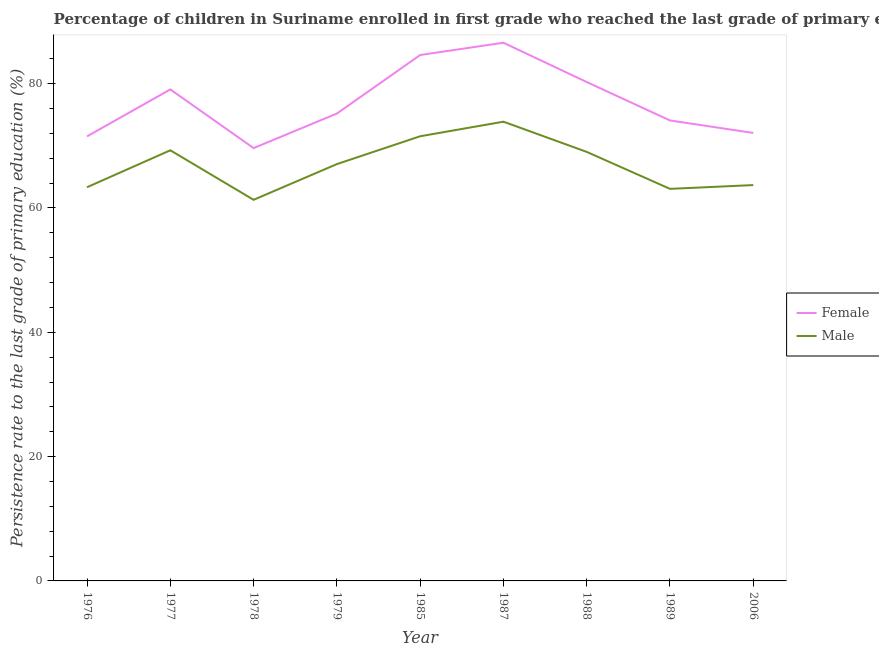Does the line corresponding to persistence rate of male students intersect with the line corresponding to persistence rate of female students?
Offer a very short reply. No. What is the persistence rate of female students in 1977?
Make the answer very short. 79.07. Across all years, what is the maximum persistence rate of female students?
Your answer should be compact. 86.58. Across all years, what is the minimum persistence rate of female students?
Offer a very short reply. 69.63. In which year was the persistence rate of female students minimum?
Your answer should be compact. 1978. What is the total persistence rate of male students in the graph?
Offer a very short reply. 602.19. What is the difference between the persistence rate of female students in 1979 and that in 1987?
Your answer should be very brief. -11.39. What is the difference between the persistence rate of male students in 1987 and the persistence rate of female students in 1976?
Give a very brief answer. 2.36. What is the average persistence rate of male students per year?
Provide a succinct answer. 66.91. In the year 1987, what is the difference between the persistence rate of male students and persistence rate of female students?
Your answer should be very brief. -12.7. In how many years, is the persistence rate of male students greater than 76 %?
Keep it short and to the point. 0. What is the ratio of the persistence rate of female students in 1977 to that in 1989?
Your answer should be very brief. 1.07. Is the persistence rate of male students in 1976 less than that in 1988?
Offer a very short reply. Yes. What is the difference between the highest and the second highest persistence rate of female students?
Offer a very short reply. 1.98. What is the difference between the highest and the lowest persistence rate of female students?
Give a very brief answer. 16.95. In how many years, is the persistence rate of female students greater than the average persistence rate of female students taken over all years?
Keep it short and to the point. 4. Is the sum of the persistence rate of female students in 1978 and 1988 greater than the maximum persistence rate of male students across all years?
Your response must be concise. Yes. Does the persistence rate of female students monotonically increase over the years?
Make the answer very short. No. How many lines are there?
Offer a very short reply. 2. How many years are there in the graph?
Provide a short and direct response. 9. Does the graph contain any zero values?
Ensure brevity in your answer.  No. Does the graph contain grids?
Your answer should be compact. No. How many legend labels are there?
Provide a short and direct response. 2. How are the legend labels stacked?
Give a very brief answer. Vertical. What is the title of the graph?
Provide a succinct answer. Percentage of children in Suriname enrolled in first grade who reached the last grade of primary education. Does "Rural Population" appear as one of the legend labels in the graph?
Provide a short and direct response. No. What is the label or title of the Y-axis?
Give a very brief answer. Persistence rate to the last grade of primary education (%). What is the Persistence rate to the last grade of primary education (%) of Female in 1976?
Your answer should be very brief. 71.52. What is the Persistence rate to the last grade of primary education (%) in Male in 1976?
Provide a succinct answer. 63.34. What is the Persistence rate to the last grade of primary education (%) in Female in 1977?
Offer a very short reply. 79.07. What is the Persistence rate to the last grade of primary education (%) of Male in 1977?
Give a very brief answer. 69.28. What is the Persistence rate to the last grade of primary education (%) of Female in 1978?
Ensure brevity in your answer.  69.63. What is the Persistence rate to the last grade of primary education (%) in Male in 1978?
Your answer should be very brief. 61.31. What is the Persistence rate to the last grade of primary education (%) in Female in 1979?
Offer a terse response. 75.19. What is the Persistence rate to the last grade of primary education (%) in Male in 1979?
Offer a terse response. 67.06. What is the Persistence rate to the last grade of primary education (%) in Female in 1985?
Provide a succinct answer. 84.61. What is the Persistence rate to the last grade of primary education (%) of Male in 1985?
Your response must be concise. 71.54. What is the Persistence rate to the last grade of primary education (%) of Female in 1987?
Provide a succinct answer. 86.58. What is the Persistence rate to the last grade of primary education (%) in Male in 1987?
Your answer should be very brief. 73.88. What is the Persistence rate to the last grade of primary education (%) of Female in 1988?
Make the answer very short. 80.26. What is the Persistence rate to the last grade of primary education (%) in Male in 1988?
Provide a succinct answer. 69.02. What is the Persistence rate to the last grade of primary education (%) of Female in 1989?
Offer a very short reply. 74.08. What is the Persistence rate to the last grade of primary education (%) in Male in 1989?
Give a very brief answer. 63.08. What is the Persistence rate to the last grade of primary education (%) in Female in 2006?
Offer a terse response. 72.07. What is the Persistence rate to the last grade of primary education (%) of Male in 2006?
Offer a terse response. 63.68. Across all years, what is the maximum Persistence rate to the last grade of primary education (%) in Female?
Provide a succinct answer. 86.58. Across all years, what is the maximum Persistence rate to the last grade of primary education (%) in Male?
Offer a terse response. 73.88. Across all years, what is the minimum Persistence rate to the last grade of primary education (%) of Female?
Ensure brevity in your answer.  69.63. Across all years, what is the minimum Persistence rate to the last grade of primary education (%) in Male?
Your answer should be compact. 61.31. What is the total Persistence rate to the last grade of primary education (%) in Female in the graph?
Your answer should be compact. 693.01. What is the total Persistence rate to the last grade of primary education (%) in Male in the graph?
Your answer should be compact. 602.19. What is the difference between the Persistence rate to the last grade of primary education (%) in Female in 1976 and that in 1977?
Offer a very short reply. -7.56. What is the difference between the Persistence rate to the last grade of primary education (%) of Male in 1976 and that in 1977?
Offer a terse response. -5.94. What is the difference between the Persistence rate to the last grade of primary education (%) in Female in 1976 and that in 1978?
Make the answer very short. 1.89. What is the difference between the Persistence rate to the last grade of primary education (%) in Male in 1976 and that in 1978?
Ensure brevity in your answer.  2.03. What is the difference between the Persistence rate to the last grade of primary education (%) of Female in 1976 and that in 1979?
Provide a succinct answer. -3.67. What is the difference between the Persistence rate to the last grade of primary education (%) of Male in 1976 and that in 1979?
Make the answer very short. -3.72. What is the difference between the Persistence rate to the last grade of primary education (%) of Female in 1976 and that in 1985?
Offer a terse response. -13.09. What is the difference between the Persistence rate to the last grade of primary education (%) of Male in 1976 and that in 1985?
Your response must be concise. -8.2. What is the difference between the Persistence rate to the last grade of primary education (%) of Female in 1976 and that in 1987?
Give a very brief answer. -15.07. What is the difference between the Persistence rate to the last grade of primary education (%) of Male in 1976 and that in 1987?
Offer a very short reply. -10.54. What is the difference between the Persistence rate to the last grade of primary education (%) of Female in 1976 and that in 1988?
Provide a succinct answer. -8.74. What is the difference between the Persistence rate to the last grade of primary education (%) of Male in 1976 and that in 1988?
Your answer should be compact. -5.68. What is the difference between the Persistence rate to the last grade of primary education (%) in Female in 1976 and that in 1989?
Offer a terse response. -2.56. What is the difference between the Persistence rate to the last grade of primary education (%) of Male in 1976 and that in 1989?
Your response must be concise. 0.26. What is the difference between the Persistence rate to the last grade of primary education (%) in Female in 1976 and that in 2006?
Provide a succinct answer. -0.55. What is the difference between the Persistence rate to the last grade of primary education (%) in Male in 1976 and that in 2006?
Your answer should be very brief. -0.34. What is the difference between the Persistence rate to the last grade of primary education (%) of Female in 1977 and that in 1978?
Your response must be concise. 9.44. What is the difference between the Persistence rate to the last grade of primary education (%) in Male in 1977 and that in 1978?
Provide a succinct answer. 7.97. What is the difference between the Persistence rate to the last grade of primary education (%) of Female in 1977 and that in 1979?
Provide a short and direct response. 3.88. What is the difference between the Persistence rate to the last grade of primary education (%) of Male in 1977 and that in 1979?
Your answer should be very brief. 2.22. What is the difference between the Persistence rate to the last grade of primary education (%) in Female in 1977 and that in 1985?
Provide a succinct answer. -5.53. What is the difference between the Persistence rate to the last grade of primary education (%) of Male in 1977 and that in 1985?
Your response must be concise. -2.26. What is the difference between the Persistence rate to the last grade of primary education (%) in Female in 1977 and that in 1987?
Your answer should be compact. -7.51. What is the difference between the Persistence rate to the last grade of primary education (%) of Male in 1977 and that in 1987?
Ensure brevity in your answer.  -4.6. What is the difference between the Persistence rate to the last grade of primary education (%) in Female in 1977 and that in 1988?
Give a very brief answer. -1.19. What is the difference between the Persistence rate to the last grade of primary education (%) of Male in 1977 and that in 1988?
Offer a very short reply. 0.26. What is the difference between the Persistence rate to the last grade of primary education (%) of Female in 1977 and that in 1989?
Ensure brevity in your answer.  4.99. What is the difference between the Persistence rate to the last grade of primary education (%) of Male in 1977 and that in 1989?
Ensure brevity in your answer.  6.2. What is the difference between the Persistence rate to the last grade of primary education (%) of Female in 1977 and that in 2006?
Ensure brevity in your answer.  7. What is the difference between the Persistence rate to the last grade of primary education (%) in Male in 1977 and that in 2006?
Your answer should be very brief. 5.6. What is the difference between the Persistence rate to the last grade of primary education (%) of Female in 1978 and that in 1979?
Your answer should be very brief. -5.56. What is the difference between the Persistence rate to the last grade of primary education (%) in Male in 1978 and that in 1979?
Provide a succinct answer. -5.75. What is the difference between the Persistence rate to the last grade of primary education (%) of Female in 1978 and that in 1985?
Provide a short and direct response. -14.98. What is the difference between the Persistence rate to the last grade of primary education (%) of Male in 1978 and that in 1985?
Provide a succinct answer. -10.22. What is the difference between the Persistence rate to the last grade of primary education (%) in Female in 1978 and that in 1987?
Your answer should be very brief. -16.95. What is the difference between the Persistence rate to the last grade of primary education (%) in Male in 1978 and that in 1987?
Provide a succinct answer. -12.57. What is the difference between the Persistence rate to the last grade of primary education (%) in Female in 1978 and that in 1988?
Provide a short and direct response. -10.63. What is the difference between the Persistence rate to the last grade of primary education (%) in Male in 1978 and that in 1988?
Provide a short and direct response. -7.71. What is the difference between the Persistence rate to the last grade of primary education (%) in Female in 1978 and that in 1989?
Make the answer very short. -4.45. What is the difference between the Persistence rate to the last grade of primary education (%) in Male in 1978 and that in 1989?
Your answer should be very brief. -1.76. What is the difference between the Persistence rate to the last grade of primary education (%) of Female in 1978 and that in 2006?
Give a very brief answer. -2.44. What is the difference between the Persistence rate to the last grade of primary education (%) of Male in 1978 and that in 2006?
Your response must be concise. -2.37. What is the difference between the Persistence rate to the last grade of primary education (%) of Female in 1979 and that in 1985?
Offer a terse response. -9.42. What is the difference between the Persistence rate to the last grade of primary education (%) of Male in 1979 and that in 1985?
Ensure brevity in your answer.  -4.48. What is the difference between the Persistence rate to the last grade of primary education (%) of Female in 1979 and that in 1987?
Offer a terse response. -11.39. What is the difference between the Persistence rate to the last grade of primary education (%) in Male in 1979 and that in 1987?
Your response must be concise. -6.82. What is the difference between the Persistence rate to the last grade of primary education (%) of Female in 1979 and that in 1988?
Offer a very short reply. -5.07. What is the difference between the Persistence rate to the last grade of primary education (%) of Male in 1979 and that in 1988?
Your answer should be very brief. -1.96. What is the difference between the Persistence rate to the last grade of primary education (%) in Female in 1979 and that in 1989?
Give a very brief answer. 1.11. What is the difference between the Persistence rate to the last grade of primary education (%) in Male in 1979 and that in 1989?
Give a very brief answer. 3.98. What is the difference between the Persistence rate to the last grade of primary education (%) of Female in 1979 and that in 2006?
Your answer should be very brief. 3.12. What is the difference between the Persistence rate to the last grade of primary education (%) of Male in 1979 and that in 2006?
Your answer should be compact. 3.38. What is the difference between the Persistence rate to the last grade of primary education (%) in Female in 1985 and that in 1987?
Your answer should be very brief. -1.98. What is the difference between the Persistence rate to the last grade of primary education (%) of Male in 1985 and that in 1987?
Your response must be concise. -2.35. What is the difference between the Persistence rate to the last grade of primary education (%) of Female in 1985 and that in 1988?
Offer a very short reply. 4.35. What is the difference between the Persistence rate to the last grade of primary education (%) of Male in 1985 and that in 1988?
Offer a very short reply. 2.52. What is the difference between the Persistence rate to the last grade of primary education (%) in Female in 1985 and that in 1989?
Keep it short and to the point. 10.53. What is the difference between the Persistence rate to the last grade of primary education (%) in Male in 1985 and that in 1989?
Offer a terse response. 8.46. What is the difference between the Persistence rate to the last grade of primary education (%) of Female in 1985 and that in 2006?
Give a very brief answer. 12.54. What is the difference between the Persistence rate to the last grade of primary education (%) in Male in 1985 and that in 2006?
Provide a succinct answer. 7.85. What is the difference between the Persistence rate to the last grade of primary education (%) of Female in 1987 and that in 1988?
Offer a very short reply. 6.32. What is the difference between the Persistence rate to the last grade of primary education (%) of Male in 1987 and that in 1988?
Ensure brevity in your answer.  4.86. What is the difference between the Persistence rate to the last grade of primary education (%) in Female in 1987 and that in 1989?
Give a very brief answer. 12.5. What is the difference between the Persistence rate to the last grade of primary education (%) in Male in 1987 and that in 1989?
Provide a short and direct response. 10.81. What is the difference between the Persistence rate to the last grade of primary education (%) of Female in 1987 and that in 2006?
Offer a terse response. 14.51. What is the difference between the Persistence rate to the last grade of primary education (%) in Male in 1987 and that in 2006?
Your answer should be compact. 10.2. What is the difference between the Persistence rate to the last grade of primary education (%) of Female in 1988 and that in 1989?
Your response must be concise. 6.18. What is the difference between the Persistence rate to the last grade of primary education (%) in Male in 1988 and that in 1989?
Make the answer very short. 5.95. What is the difference between the Persistence rate to the last grade of primary education (%) in Female in 1988 and that in 2006?
Provide a succinct answer. 8.19. What is the difference between the Persistence rate to the last grade of primary education (%) of Male in 1988 and that in 2006?
Make the answer very short. 5.34. What is the difference between the Persistence rate to the last grade of primary education (%) of Female in 1989 and that in 2006?
Provide a short and direct response. 2.01. What is the difference between the Persistence rate to the last grade of primary education (%) of Male in 1989 and that in 2006?
Make the answer very short. -0.61. What is the difference between the Persistence rate to the last grade of primary education (%) of Female in 1976 and the Persistence rate to the last grade of primary education (%) of Male in 1977?
Offer a terse response. 2.24. What is the difference between the Persistence rate to the last grade of primary education (%) of Female in 1976 and the Persistence rate to the last grade of primary education (%) of Male in 1978?
Give a very brief answer. 10.21. What is the difference between the Persistence rate to the last grade of primary education (%) in Female in 1976 and the Persistence rate to the last grade of primary education (%) in Male in 1979?
Your answer should be compact. 4.46. What is the difference between the Persistence rate to the last grade of primary education (%) of Female in 1976 and the Persistence rate to the last grade of primary education (%) of Male in 1985?
Your response must be concise. -0.02. What is the difference between the Persistence rate to the last grade of primary education (%) in Female in 1976 and the Persistence rate to the last grade of primary education (%) in Male in 1987?
Give a very brief answer. -2.36. What is the difference between the Persistence rate to the last grade of primary education (%) of Female in 1976 and the Persistence rate to the last grade of primary education (%) of Male in 1988?
Ensure brevity in your answer.  2.5. What is the difference between the Persistence rate to the last grade of primary education (%) in Female in 1976 and the Persistence rate to the last grade of primary education (%) in Male in 1989?
Make the answer very short. 8.44. What is the difference between the Persistence rate to the last grade of primary education (%) of Female in 1976 and the Persistence rate to the last grade of primary education (%) of Male in 2006?
Provide a short and direct response. 7.84. What is the difference between the Persistence rate to the last grade of primary education (%) in Female in 1977 and the Persistence rate to the last grade of primary education (%) in Male in 1978?
Make the answer very short. 17.76. What is the difference between the Persistence rate to the last grade of primary education (%) of Female in 1977 and the Persistence rate to the last grade of primary education (%) of Male in 1979?
Ensure brevity in your answer.  12.02. What is the difference between the Persistence rate to the last grade of primary education (%) in Female in 1977 and the Persistence rate to the last grade of primary education (%) in Male in 1985?
Ensure brevity in your answer.  7.54. What is the difference between the Persistence rate to the last grade of primary education (%) in Female in 1977 and the Persistence rate to the last grade of primary education (%) in Male in 1987?
Offer a very short reply. 5.19. What is the difference between the Persistence rate to the last grade of primary education (%) of Female in 1977 and the Persistence rate to the last grade of primary education (%) of Male in 1988?
Keep it short and to the point. 10.05. What is the difference between the Persistence rate to the last grade of primary education (%) of Female in 1977 and the Persistence rate to the last grade of primary education (%) of Male in 1989?
Ensure brevity in your answer.  16. What is the difference between the Persistence rate to the last grade of primary education (%) of Female in 1977 and the Persistence rate to the last grade of primary education (%) of Male in 2006?
Provide a succinct answer. 15.39. What is the difference between the Persistence rate to the last grade of primary education (%) in Female in 1978 and the Persistence rate to the last grade of primary education (%) in Male in 1979?
Keep it short and to the point. 2.57. What is the difference between the Persistence rate to the last grade of primary education (%) in Female in 1978 and the Persistence rate to the last grade of primary education (%) in Male in 1985?
Make the answer very short. -1.91. What is the difference between the Persistence rate to the last grade of primary education (%) in Female in 1978 and the Persistence rate to the last grade of primary education (%) in Male in 1987?
Your answer should be very brief. -4.25. What is the difference between the Persistence rate to the last grade of primary education (%) in Female in 1978 and the Persistence rate to the last grade of primary education (%) in Male in 1988?
Give a very brief answer. 0.61. What is the difference between the Persistence rate to the last grade of primary education (%) of Female in 1978 and the Persistence rate to the last grade of primary education (%) of Male in 1989?
Provide a short and direct response. 6.55. What is the difference between the Persistence rate to the last grade of primary education (%) in Female in 1978 and the Persistence rate to the last grade of primary education (%) in Male in 2006?
Keep it short and to the point. 5.95. What is the difference between the Persistence rate to the last grade of primary education (%) in Female in 1979 and the Persistence rate to the last grade of primary education (%) in Male in 1985?
Provide a short and direct response. 3.65. What is the difference between the Persistence rate to the last grade of primary education (%) in Female in 1979 and the Persistence rate to the last grade of primary education (%) in Male in 1987?
Your answer should be very brief. 1.31. What is the difference between the Persistence rate to the last grade of primary education (%) of Female in 1979 and the Persistence rate to the last grade of primary education (%) of Male in 1988?
Provide a succinct answer. 6.17. What is the difference between the Persistence rate to the last grade of primary education (%) of Female in 1979 and the Persistence rate to the last grade of primary education (%) of Male in 1989?
Offer a terse response. 12.11. What is the difference between the Persistence rate to the last grade of primary education (%) in Female in 1979 and the Persistence rate to the last grade of primary education (%) in Male in 2006?
Give a very brief answer. 11.51. What is the difference between the Persistence rate to the last grade of primary education (%) of Female in 1985 and the Persistence rate to the last grade of primary education (%) of Male in 1987?
Keep it short and to the point. 10.72. What is the difference between the Persistence rate to the last grade of primary education (%) of Female in 1985 and the Persistence rate to the last grade of primary education (%) of Male in 1988?
Your response must be concise. 15.59. What is the difference between the Persistence rate to the last grade of primary education (%) in Female in 1985 and the Persistence rate to the last grade of primary education (%) in Male in 1989?
Your answer should be very brief. 21.53. What is the difference between the Persistence rate to the last grade of primary education (%) of Female in 1985 and the Persistence rate to the last grade of primary education (%) of Male in 2006?
Your answer should be very brief. 20.93. What is the difference between the Persistence rate to the last grade of primary education (%) of Female in 1987 and the Persistence rate to the last grade of primary education (%) of Male in 1988?
Give a very brief answer. 17.56. What is the difference between the Persistence rate to the last grade of primary education (%) of Female in 1987 and the Persistence rate to the last grade of primary education (%) of Male in 1989?
Your response must be concise. 23.51. What is the difference between the Persistence rate to the last grade of primary education (%) in Female in 1987 and the Persistence rate to the last grade of primary education (%) in Male in 2006?
Give a very brief answer. 22.9. What is the difference between the Persistence rate to the last grade of primary education (%) in Female in 1988 and the Persistence rate to the last grade of primary education (%) in Male in 1989?
Offer a terse response. 17.18. What is the difference between the Persistence rate to the last grade of primary education (%) of Female in 1988 and the Persistence rate to the last grade of primary education (%) of Male in 2006?
Make the answer very short. 16.58. What is the difference between the Persistence rate to the last grade of primary education (%) in Female in 1989 and the Persistence rate to the last grade of primary education (%) in Male in 2006?
Provide a succinct answer. 10.4. What is the average Persistence rate to the last grade of primary education (%) of Female per year?
Ensure brevity in your answer.  77. What is the average Persistence rate to the last grade of primary education (%) in Male per year?
Offer a terse response. 66.91. In the year 1976, what is the difference between the Persistence rate to the last grade of primary education (%) of Female and Persistence rate to the last grade of primary education (%) of Male?
Ensure brevity in your answer.  8.18. In the year 1977, what is the difference between the Persistence rate to the last grade of primary education (%) of Female and Persistence rate to the last grade of primary education (%) of Male?
Ensure brevity in your answer.  9.79. In the year 1978, what is the difference between the Persistence rate to the last grade of primary education (%) in Female and Persistence rate to the last grade of primary education (%) in Male?
Your answer should be very brief. 8.32. In the year 1979, what is the difference between the Persistence rate to the last grade of primary education (%) of Female and Persistence rate to the last grade of primary education (%) of Male?
Your response must be concise. 8.13. In the year 1985, what is the difference between the Persistence rate to the last grade of primary education (%) of Female and Persistence rate to the last grade of primary education (%) of Male?
Provide a succinct answer. 13.07. In the year 1987, what is the difference between the Persistence rate to the last grade of primary education (%) in Female and Persistence rate to the last grade of primary education (%) in Male?
Offer a very short reply. 12.7. In the year 1988, what is the difference between the Persistence rate to the last grade of primary education (%) of Female and Persistence rate to the last grade of primary education (%) of Male?
Keep it short and to the point. 11.24. In the year 1989, what is the difference between the Persistence rate to the last grade of primary education (%) in Female and Persistence rate to the last grade of primary education (%) in Male?
Ensure brevity in your answer.  11. In the year 2006, what is the difference between the Persistence rate to the last grade of primary education (%) in Female and Persistence rate to the last grade of primary education (%) in Male?
Provide a succinct answer. 8.39. What is the ratio of the Persistence rate to the last grade of primary education (%) in Female in 1976 to that in 1977?
Make the answer very short. 0.9. What is the ratio of the Persistence rate to the last grade of primary education (%) in Male in 1976 to that in 1977?
Your response must be concise. 0.91. What is the ratio of the Persistence rate to the last grade of primary education (%) of Female in 1976 to that in 1978?
Keep it short and to the point. 1.03. What is the ratio of the Persistence rate to the last grade of primary education (%) of Male in 1976 to that in 1978?
Your answer should be very brief. 1.03. What is the ratio of the Persistence rate to the last grade of primary education (%) of Female in 1976 to that in 1979?
Your answer should be very brief. 0.95. What is the ratio of the Persistence rate to the last grade of primary education (%) in Male in 1976 to that in 1979?
Your answer should be very brief. 0.94. What is the ratio of the Persistence rate to the last grade of primary education (%) of Female in 1976 to that in 1985?
Your response must be concise. 0.85. What is the ratio of the Persistence rate to the last grade of primary education (%) of Male in 1976 to that in 1985?
Give a very brief answer. 0.89. What is the ratio of the Persistence rate to the last grade of primary education (%) of Female in 1976 to that in 1987?
Make the answer very short. 0.83. What is the ratio of the Persistence rate to the last grade of primary education (%) in Male in 1976 to that in 1987?
Ensure brevity in your answer.  0.86. What is the ratio of the Persistence rate to the last grade of primary education (%) of Female in 1976 to that in 1988?
Offer a terse response. 0.89. What is the ratio of the Persistence rate to the last grade of primary education (%) in Male in 1976 to that in 1988?
Ensure brevity in your answer.  0.92. What is the ratio of the Persistence rate to the last grade of primary education (%) of Female in 1976 to that in 1989?
Give a very brief answer. 0.97. What is the ratio of the Persistence rate to the last grade of primary education (%) in Male in 1976 to that in 2006?
Provide a succinct answer. 0.99. What is the ratio of the Persistence rate to the last grade of primary education (%) of Female in 1977 to that in 1978?
Your response must be concise. 1.14. What is the ratio of the Persistence rate to the last grade of primary education (%) in Male in 1977 to that in 1978?
Provide a succinct answer. 1.13. What is the ratio of the Persistence rate to the last grade of primary education (%) of Female in 1977 to that in 1979?
Your response must be concise. 1.05. What is the ratio of the Persistence rate to the last grade of primary education (%) in Male in 1977 to that in 1979?
Give a very brief answer. 1.03. What is the ratio of the Persistence rate to the last grade of primary education (%) in Female in 1977 to that in 1985?
Offer a very short reply. 0.93. What is the ratio of the Persistence rate to the last grade of primary education (%) in Male in 1977 to that in 1985?
Your answer should be very brief. 0.97. What is the ratio of the Persistence rate to the last grade of primary education (%) in Female in 1977 to that in 1987?
Provide a short and direct response. 0.91. What is the ratio of the Persistence rate to the last grade of primary education (%) in Male in 1977 to that in 1987?
Your answer should be compact. 0.94. What is the ratio of the Persistence rate to the last grade of primary education (%) in Female in 1977 to that in 1988?
Keep it short and to the point. 0.99. What is the ratio of the Persistence rate to the last grade of primary education (%) in Female in 1977 to that in 1989?
Your response must be concise. 1.07. What is the ratio of the Persistence rate to the last grade of primary education (%) in Male in 1977 to that in 1989?
Offer a terse response. 1.1. What is the ratio of the Persistence rate to the last grade of primary education (%) of Female in 1977 to that in 2006?
Provide a succinct answer. 1.1. What is the ratio of the Persistence rate to the last grade of primary education (%) in Male in 1977 to that in 2006?
Offer a very short reply. 1.09. What is the ratio of the Persistence rate to the last grade of primary education (%) of Female in 1978 to that in 1979?
Make the answer very short. 0.93. What is the ratio of the Persistence rate to the last grade of primary education (%) in Male in 1978 to that in 1979?
Your answer should be compact. 0.91. What is the ratio of the Persistence rate to the last grade of primary education (%) in Female in 1978 to that in 1985?
Make the answer very short. 0.82. What is the ratio of the Persistence rate to the last grade of primary education (%) in Female in 1978 to that in 1987?
Offer a terse response. 0.8. What is the ratio of the Persistence rate to the last grade of primary education (%) of Male in 1978 to that in 1987?
Provide a succinct answer. 0.83. What is the ratio of the Persistence rate to the last grade of primary education (%) in Female in 1978 to that in 1988?
Your answer should be very brief. 0.87. What is the ratio of the Persistence rate to the last grade of primary education (%) of Male in 1978 to that in 1988?
Provide a short and direct response. 0.89. What is the ratio of the Persistence rate to the last grade of primary education (%) of Female in 1978 to that in 1989?
Offer a terse response. 0.94. What is the ratio of the Persistence rate to the last grade of primary education (%) in Male in 1978 to that in 1989?
Provide a short and direct response. 0.97. What is the ratio of the Persistence rate to the last grade of primary education (%) in Female in 1978 to that in 2006?
Ensure brevity in your answer.  0.97. What is the ratio of the Persistence rate to the last grade of primary education (%) of Male in 1978 to that in 2006?
Give a very brief answer. 0.96. What is the ratio of the Persistence rate to the last grade of primary education (%) in Female in 1979 to that in 1985?
Your response must be concise. 0.89. What is the ratio of the Persistence rate to the last grade of primary education (%) of Male in 1979 to that in 1985?
Provide a succinct answer. 0.94. What is the ratio of the Persistence rate to the last grade of primary education (%) in Female in 1979 to that in 1987?
Provide a short and direct response. 0.87. What is the ratio of the Persistence rate to the last grade of primary education (%) of Male in 1979 to that in 1987?
Your answer should be very brief. 0.91. What is the ratio of the Persistence rate to the last grade of primary education (%) in Female in 1979 to that in 1988?
Offer a terse response. 0.94. What is the ratio of the Persistence rate to the last grade of primary education (%) of Male in 1979 to that in 1988?
Provide a succinct answer. 0.97. What is the ratio of the Persistence rate to the last grade of primary education (%) of Male in 1979 to that in 1989?
Give a very brief answer. 1.06. What is the ratio of the Persistence rate to the last grade of primary education (%) of Female in 1979 to that in 2006?
Your response must be concise. 1.04. What is the ratio of the Persistence rate to the last grade of primary education (%) of Male in 1979 to that in 2006?
Your answer should be very brief. 1.05. What is the ratio of the Persistence rate to the last grade of primary education (%) of Female in 1985 to that in 1987?
Offer a very short reply. 0.98. What is the ratio of the Persistence rate to the last grade of primary education (%) of Male in 1985 to that in 1987?
Your response must be concise. 0.97. What is the ratio of the Persistence rate to the last grade of primary education (%) of Female in 1985 to that in 1988?
Your answer should be compact. 1.05. What is the ratio of the Persistence rate to the last grade of primary education (%) in Male in 1985 to that in 1988?
Offer a terse response. 1.04. What is the ratio of the Persistence rate to the last grade of primary education (%) of Female in 1985 to that in 1989?
Ensure brevity in your answer.  1.14. What is the ratio of the Persistence rate to the last grade of primary education (%) in Male in 1985 to that in 1989?
Ensure brevity in your answer.  1.13. What is the ratio of the Persistence rate to the last grade of primary education (%) of Female in 1985 to that in 2006?
Keep it short and to the point. 1.17. What is the ratio of the Persistence rate to the last grade of primary education (%) in Male in 1985 to that in 2006?
Give a very brief answer. 1.12. What is the ratio of the Persistence rate to the last grade of primary education (%) of Female in 1987 to that in 1988?
Provide a short and direct response. 1.08. What is the ratio of the Persistence rate to the last grade of primary education (%) of Male in 1987 to that in 1988?
Your response must be concise. 1.07. What is the ratio of the Persistence rate to the last grade of primary education (%) of Female in 1987 to that in 1989?
Your answer should be very brief. 1.17. What is the ratio of the Persistence rate to the last grade of primary education (%) in Male in 1987 to that in 1989?
Ensure brevity in your answer.  1.17. What is the ratio of the Persistence rate to the last grade of primary education (%) of Female in 1987 to that in 2006?
Offer a terse response. 1.2. What is the ratio of the Persistence rate to the last grade of primary education (%) of Male in 1987 to that in 2006?
Keep it short and to the point. 1.16. What is the ratio of the Persistence rate to the last grade of primary education (%) of Female in 1988 to that in 1989?
Your response must be concise. 1.08. What is the ratio of the Persistence rate to the last grade of primary education (%) of Male in 1988 to that in 1989?
Your response must be concise. 1.09. What is the ratio of the Persistence rate to the last grade of primary education (%) in Female in 1988 to that in 2006?
Provide a succinct answer. 1.11. What is the ratio of the Persistence rate to the last grade of primary education (%) of Male in 1988 to that in 2006?
Keep it short and to the point. 1.08. What is the ratio of the Persistence rate to the last grade of primary education (%) in Female in 1989 to that in 2006?
Offer a terse response. 1.03. What is the difference between the highest and the second highest Persistence rate to the last grade of primary education (%) in Female?
Provide a succinct answer. 1.98. What is the difference between the highest and the second highest Persistence rate to the last grade of primary education (%) of Male?
Ensure brevity in your answer.  2.35. What is the difference between the highest and the lowest Persistence rate to the last grade of primary education (%) in Female?
Keep it short and to the point. 16.95. What is the difference between the highest and the lowest Persistence rate to the last grade of primary education (%) in Male?
Offer a very short reply. 12.57. 